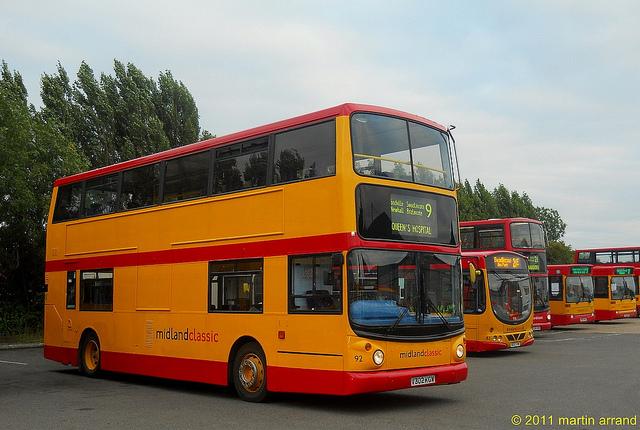How many buses are visible?
Short answer required. 6. How many levels are in the front bus?
Quick response, please. 2. What is the radio station on the ad on the front of the bus?
Concise answer only. No. What are the people on this bus doing?
Quick response, please. Waiting. What two colors are on the truck?
Answer briefly. Yellow and red. How many buses are there?
Concise answer only. 6. How many modes of transportation are pictured?
Short answer required. 1. Do the buses have wheels?
Be succinct. Yes. Is it a sunny day?
Short answer required. Yes. How many buses are here?
Keep it brief. 6. What color is the bus?
Short answer required. Orange. Is the bus in motion?
Answer briefly. No. Is one bus ahead of the other?
Keep it brief. Yes. Are these buses the same color?
Give a very brief answer. Yes. 